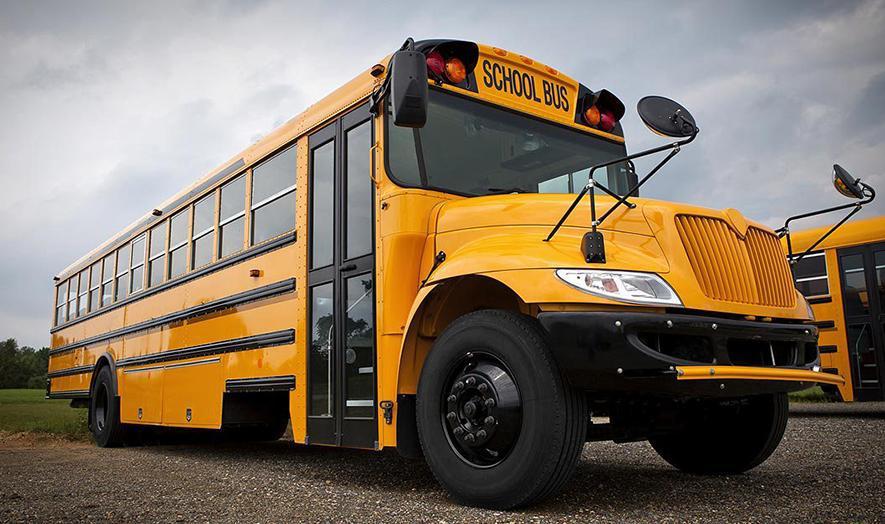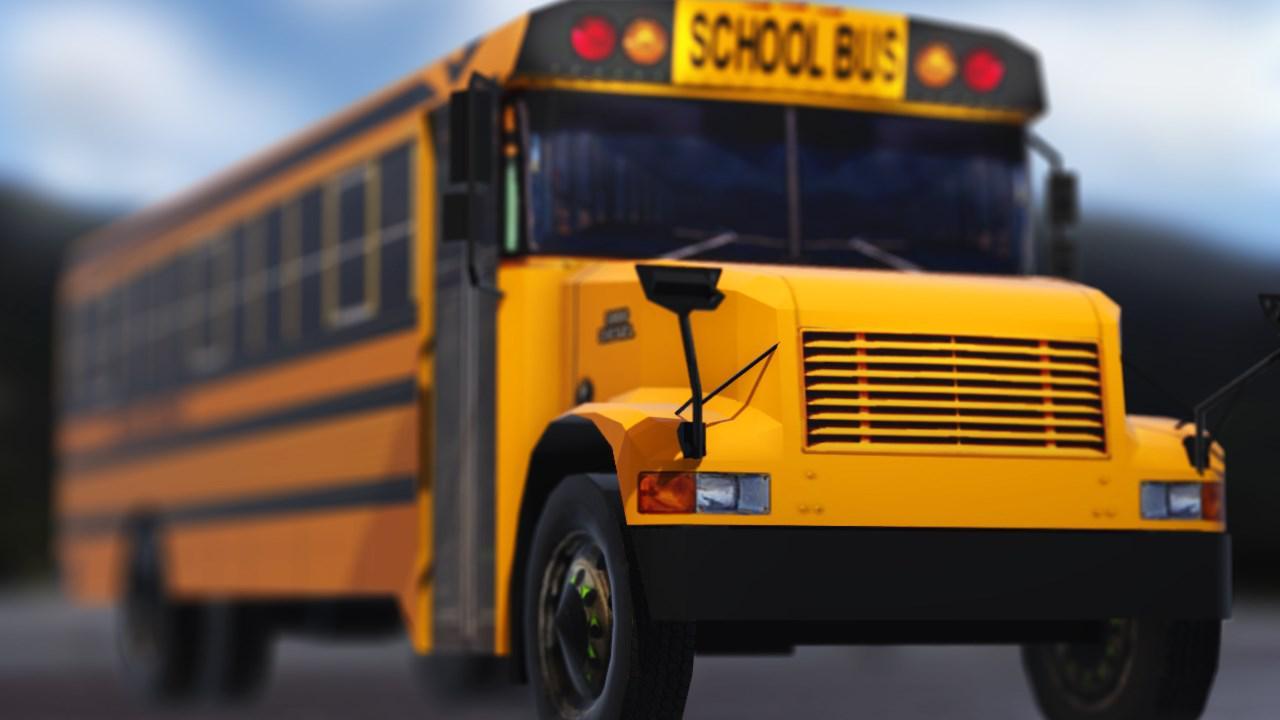The first image is the image on the left, the second image is the image on the right. Examine the images to the left and right. Is the description "All school buses are intact and angled heading rightward, with no buildings visible behind them." accurate? Answer yes or no. Yes. The first image is the image on the left, the second image is the image on the right. Assess this claim about the two images: "The right image contains a school bus that is facing towards the right.". Correct or not? Answer yes or no. Yes. 